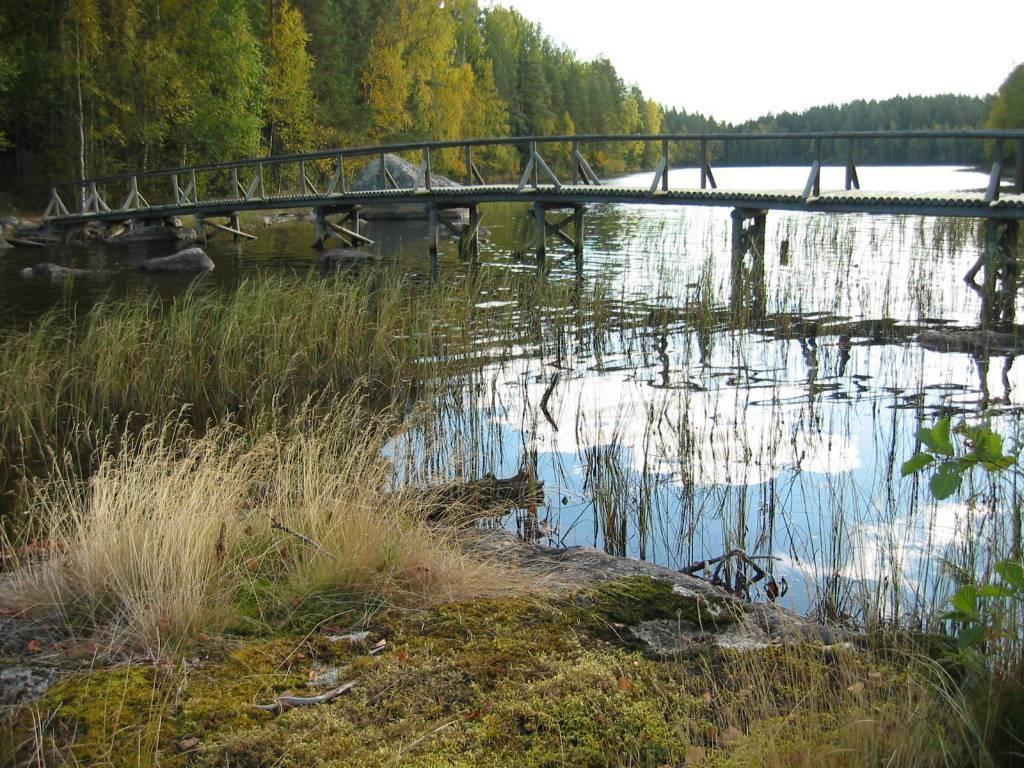Can you describe this image briefly? In this image I can see at the bottom there is the grass on these stones. In the middle it looks like a pond and there is a bridge. There are trees on either side of this image, at the top it is the cloudy sky. 